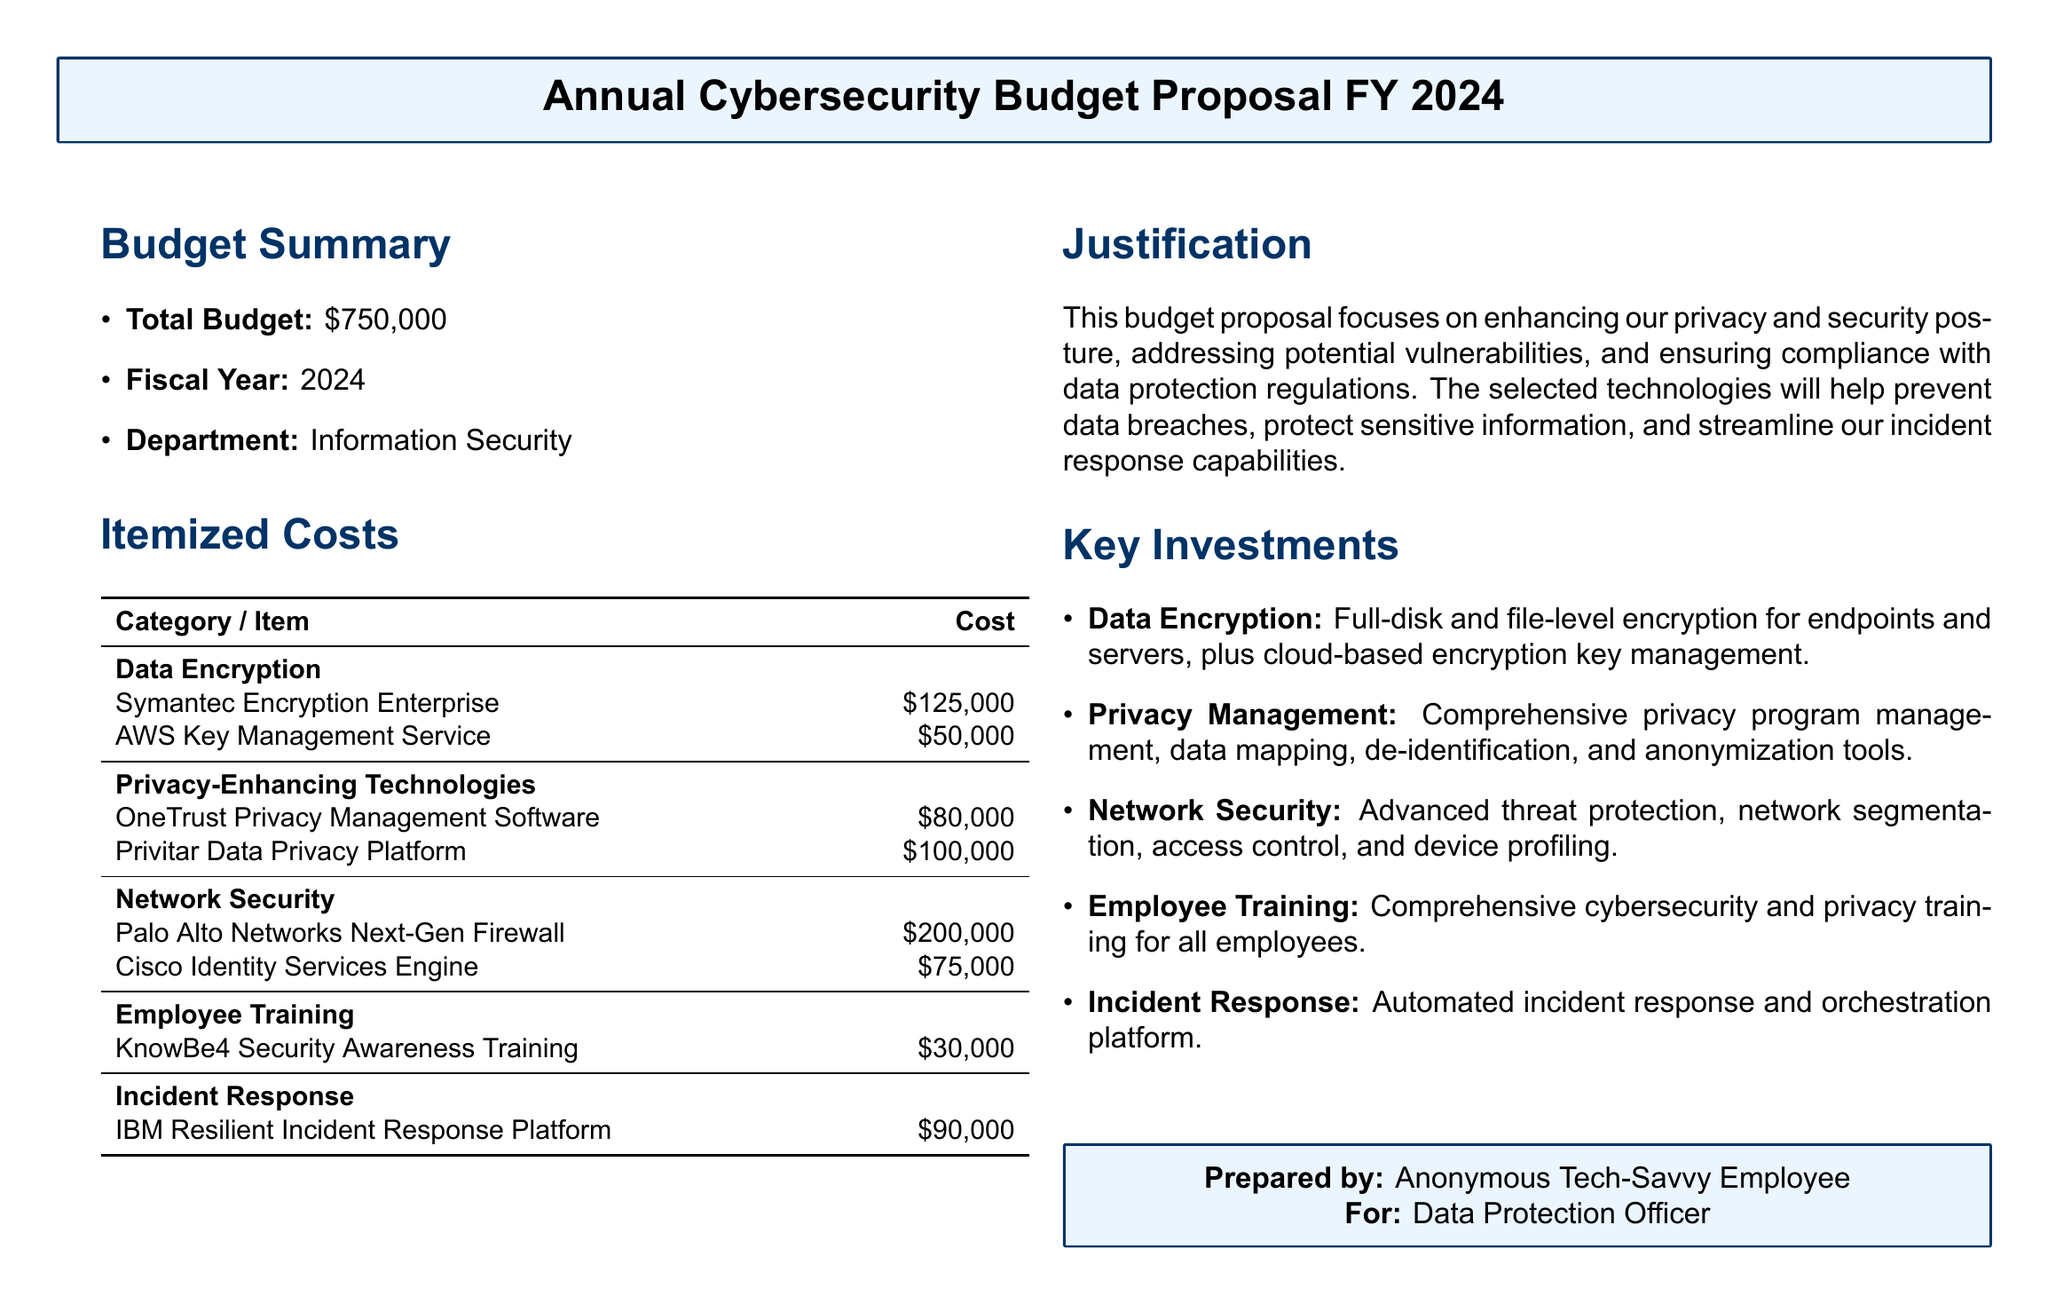What is the total budget? The total budget is stated clearly in the document and is \$750,000.
Answer: \$750,000 What is the cost of the OneTrust Privacy Management Software? The document lists the cost of OneTrust Privacy Management Software under privacy-enhancing technologies, which is \$80,000.
Answer: \$80,000 How much is allocated for data encryption? The total allocated for data encryption can be found by adding up the listed costs for the relevant items, which total \$175,000.
Answer: \$175,000 What is the cost for incident response? The document specifies the cost for the IBM Resilient Incident Response Platform under incident response, which is \$90,000.
Answer: \$90,000 What is included in employee training? The document explicitly mentions a specific training program, KnowBe4 Security Awareness Training, as part of employee training.
Answer: KnowBe4 Security Awareness Training What is the highest individual item cost in the budget? By reviewing the itemized costs, the highest individual cost is associated with the Palo Alto Networks Next-Gen Firewall, which is \$200,000.
Answer: \$200,000 How many privacy-enhancing technologies are listed? The document lists two privacy-enhancing technologies: OneTrust Privacy Management Software and Privitar Data Privacy Platform.
Answer: Two What is the purpose of the budget proposal? The justification section highlights that the purpose is to enhance privacy and security posture while ensuring compliance with data protection regulations.
Answer: Enhance privacy and security posture What department is preparing this budget proposal? The budget proposal is prepared for the Information Security department as indicated in the summary.
Answer: Information Security 